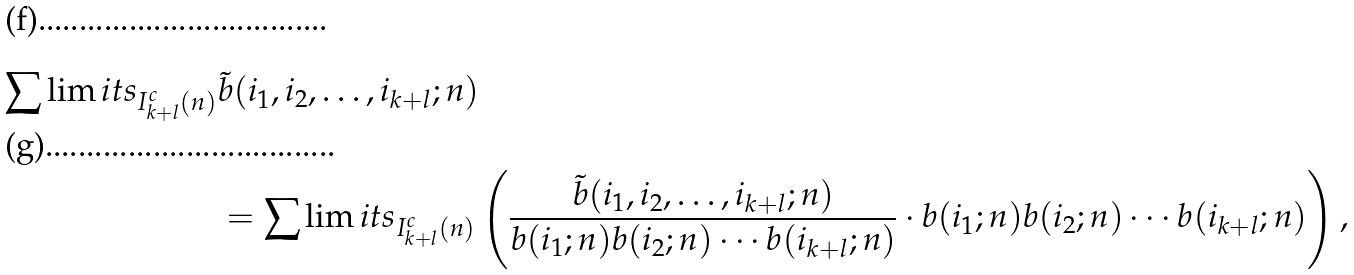<formula> <loc_0><loc_0><loc_500><loc_500>\sum \lim i t s _ { \substack { I ^ { c } _ { k + l } ( n ) } } & \tilde { b } ( i _ { 1 } , i _ { 2 } , \dots , i _ { k + l } ; n ) \\ & = \sum \lim i t s _ { \substack { I ^ { c } _ { k + l } ( n ) } } \left ( \frac { \tilde { b } ( i _ { 1 } , i _ { 2 } , \dots , i _ { k + l } ; n ) } { b ( i _ { 1 } ; n ) b ( i _ { 2 } ; n ) \cdots b ( i _ { k + l } ; n ) } \cdot b ( i _ { 1 } ; n ) b ( i _ { 2 } ; n ) \cdots b ( i _ { k + l } ; n ) \right ) ,</formula> 